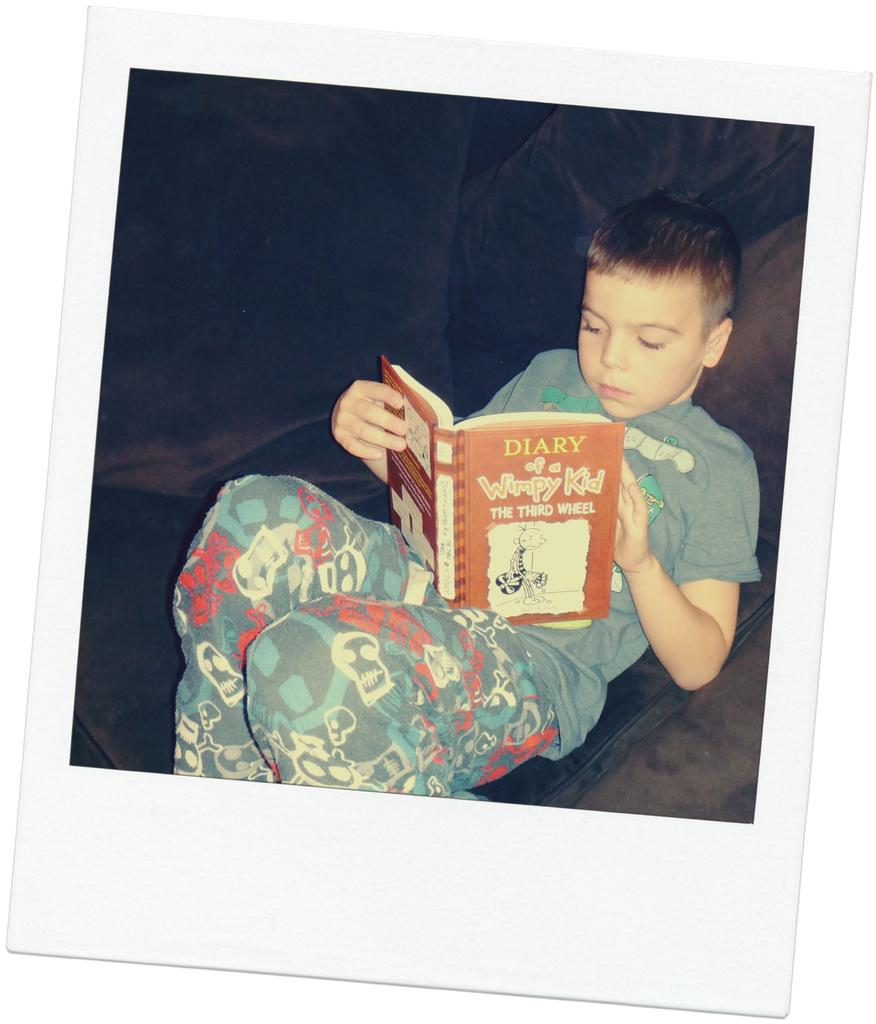<image>
Present a compact description of the photo's key features. A young boy is reading a book on a couch called Diary of a Wimpy Kid. 